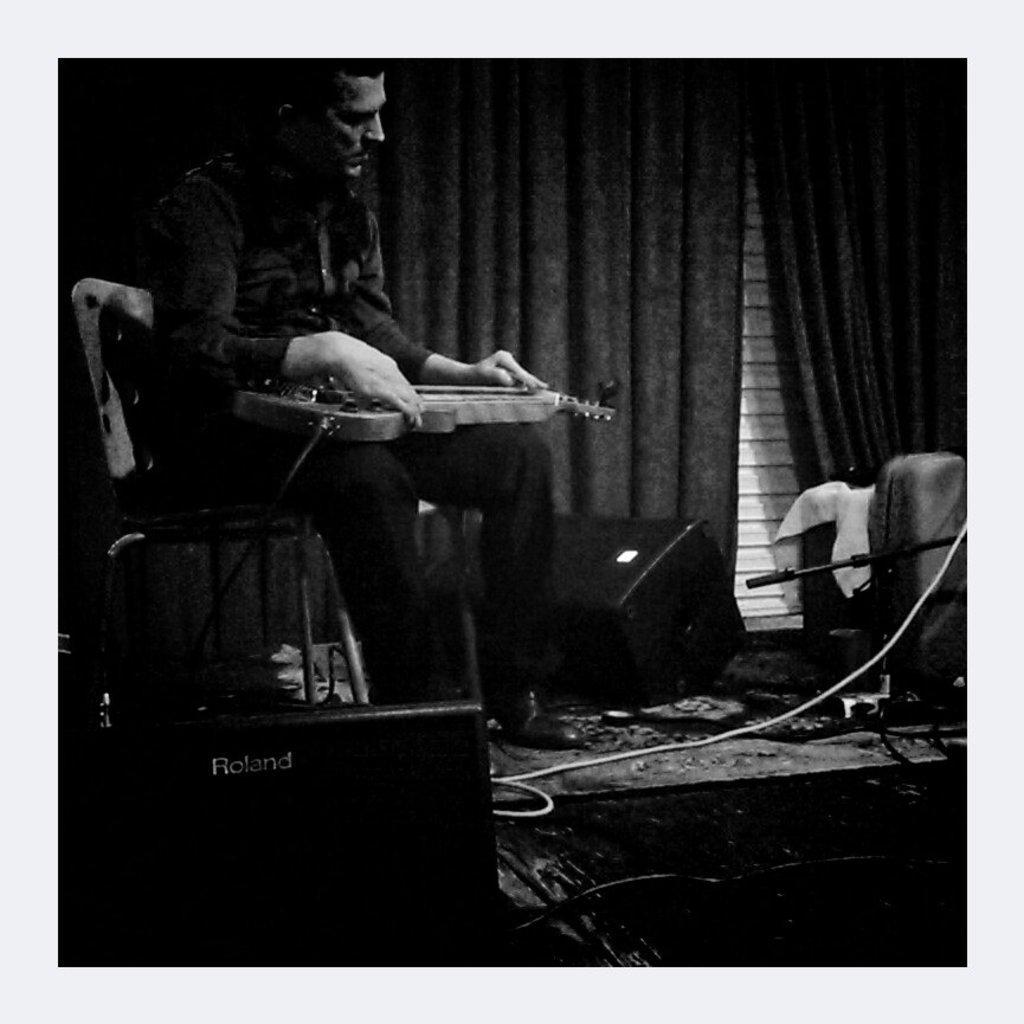Could you give a brief overview of what you see in this image? This is a black and white image. In this image we can see a person sitting on the chair and holding a musical instrument on his lap. In the background we can see speakers, electric lights and curtains. 